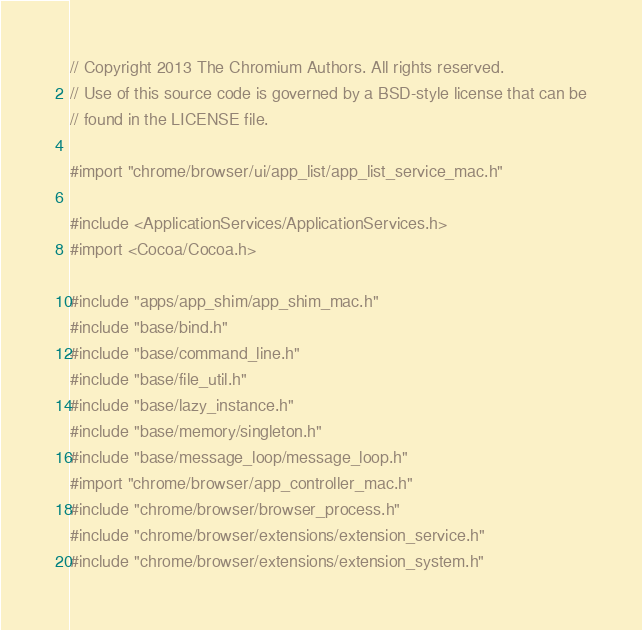<code> <loc_0><loc_0><loc_500><loc_500><_ObjectiveC_>// Copyright 2013 The Chromium Authors. All rights reserved.
// Use of this source code is governed by a BSD-style license that can be
// found in the LICENSE file.

#import "chrome/browser/ui/app_list/app_list_service_mac.h"

#include <ApplicationServices/ApplicationServices.h>
#import <Cocoa/Cocoa.h>

#include "apps/app_shim/app_shim_mac.h"
#include "base/bind.h"
#include "base/command_line.h"
#include "base/file_util.h"
#include "base/lazy_instance.h"
#include "base/memory/singleton.h"
#include "base/message_loop/message_loop.h"
#import "chrome/browser/app_controller_mac.h"
#include "chrome/browser/browser_process.h"
#include "chrome/browser/extensions/extension_service.h"
#include "chrome/browser/extensions/extension_system.h"</code> 